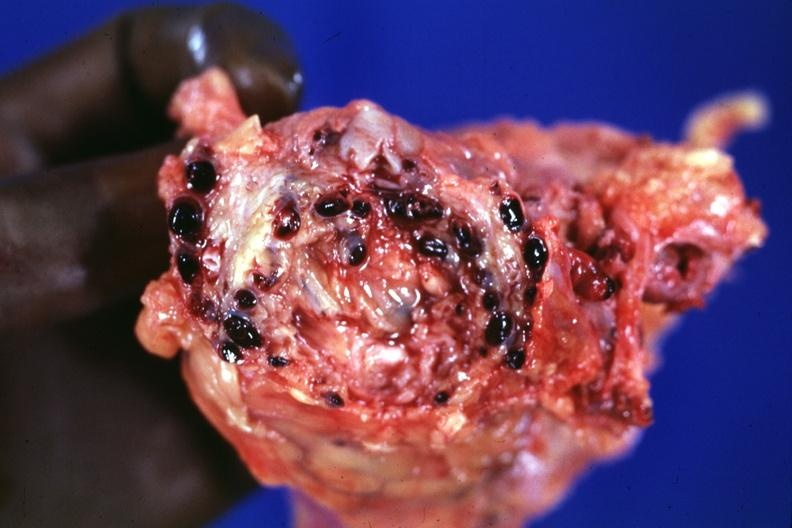what is present?
Answer the question using a single word or phrase. Prostate 